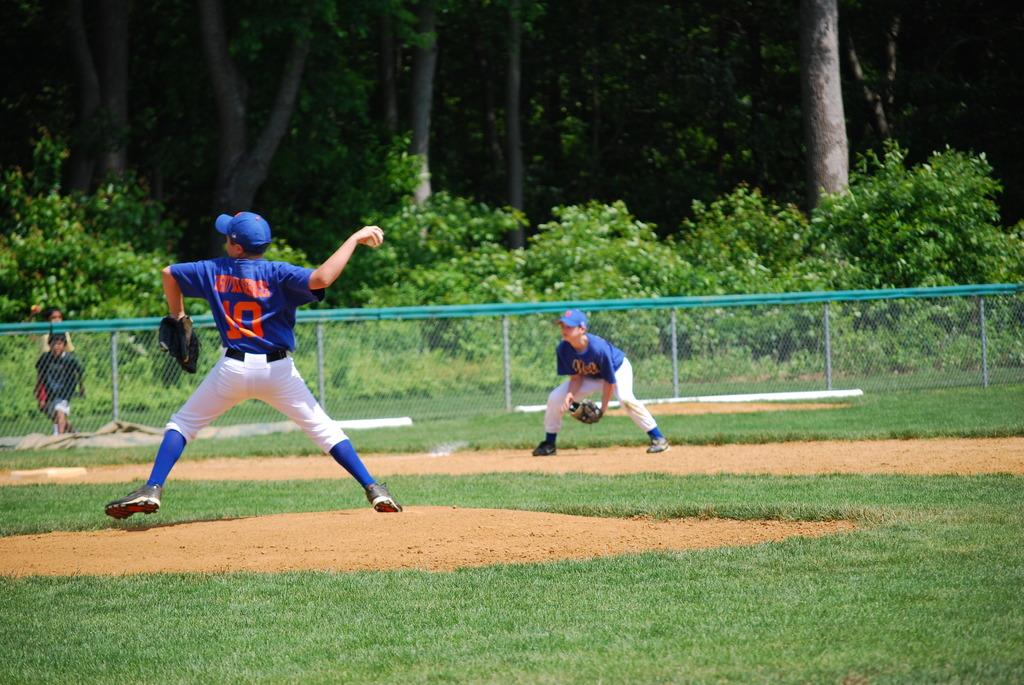<image>
Share a concise interpretation of the image provided. The player wearing no10 is throwing the ball to another player. 